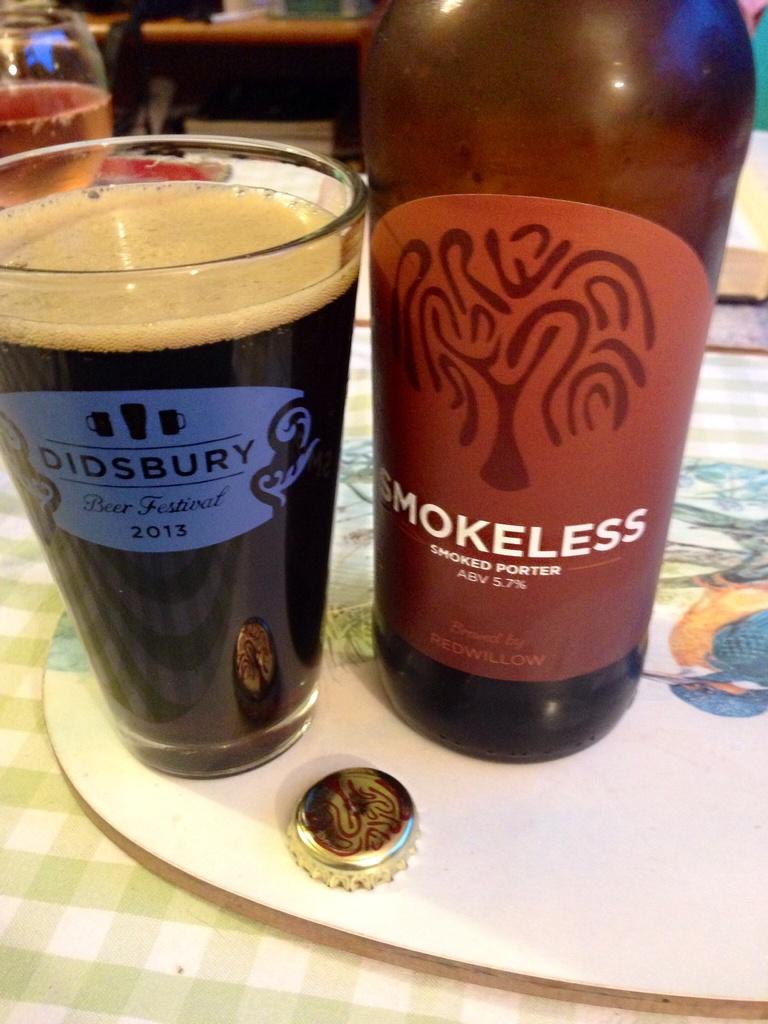What is the percentage of alcohol in the beer?
Give a very brief answer. 5.7. 